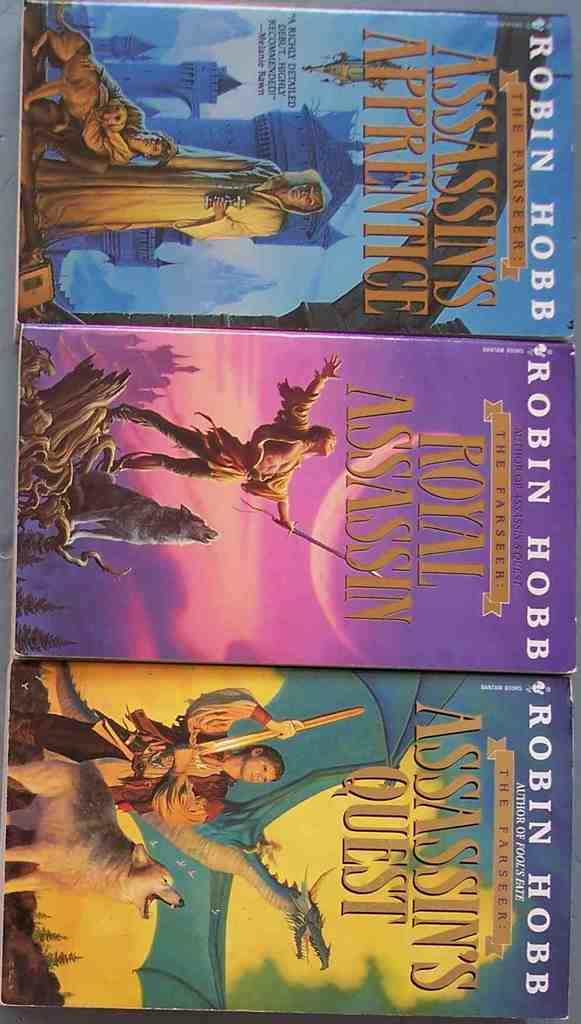<image>
Give a short and clear explanation of the subsequent image. a row of three books by robin hobb in different colors 